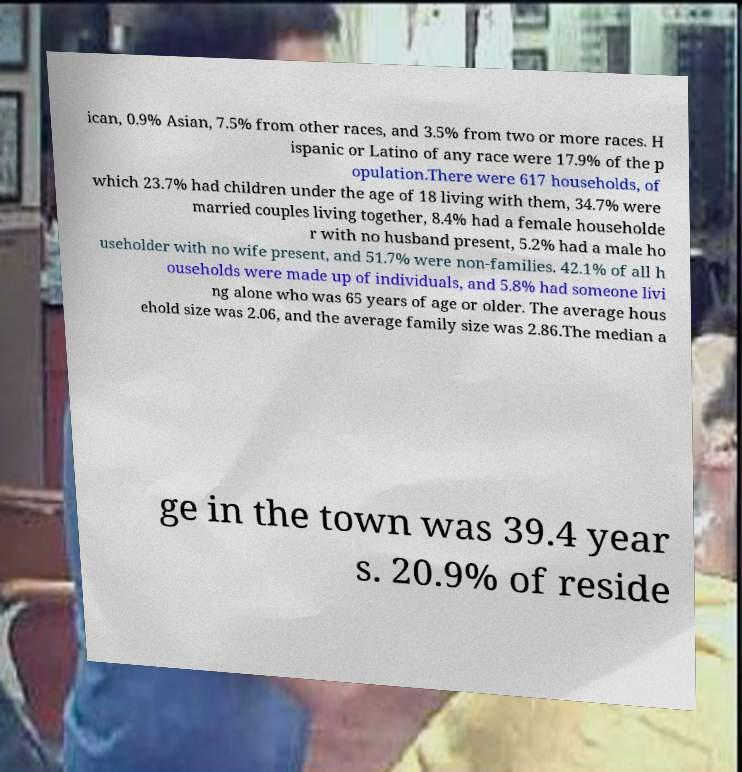There's text embedded in this image that I need extracted. Can you transcribe it verbatim? ican, 0.9% Asian, 7.5% from other races, and 3.5% from two or more races. H ispanic or Latino of any race were 17.9% of the p opulation.There were 617 households, of which 23.7% had children under the age of 18 living with them, 34.7% were married couples living together, 8.4% had a female householde r with no husband present, 5.2% had a male ho useholder with no wife present, and 51.7% were non-families. 42.1% of all h ouseholds were made up of individuals, and 5.8% had someone livi ng alone who was 65 years of age or older. The average hous ehold size was 2.06, and the average family size was 2.86.The median a ge in the town was 39.4 year s. 20.9% of reside 